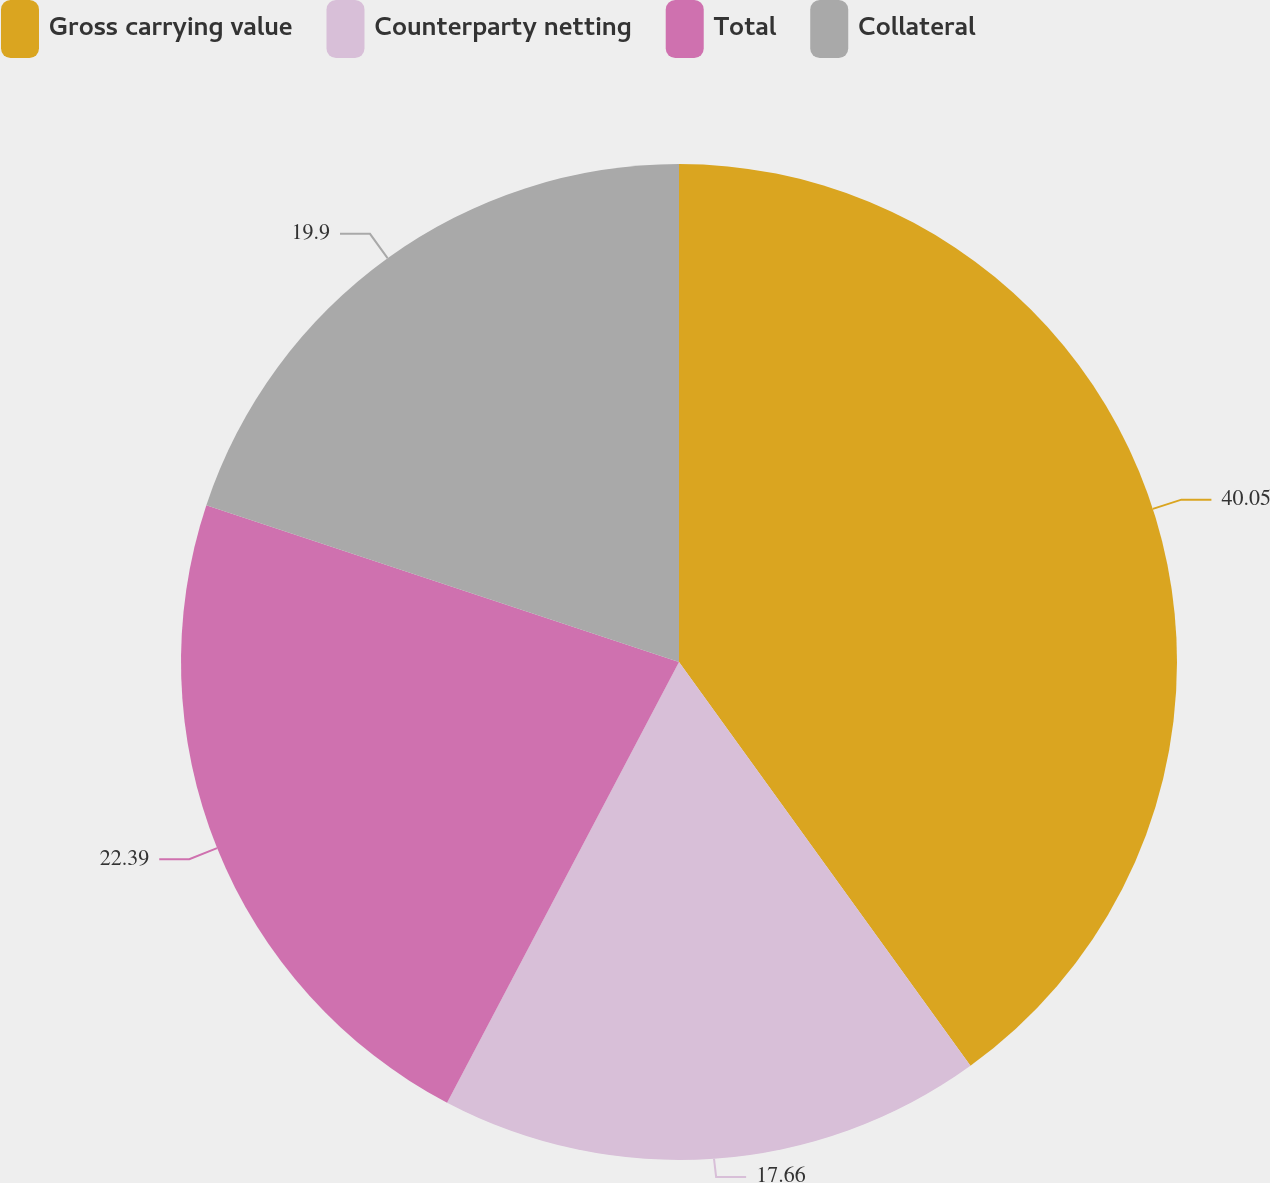<chart> <loc_0><loc_0><loc_500><loc_500><pie_chart><fcel>Gross carrying value<fcel>Counterparty netting<fcel>Total<fcel>Collateral<nl><fcel>40.05%<fcel>17.66%<fcel>22.39%<fcel>19.9%<nl></chart> 